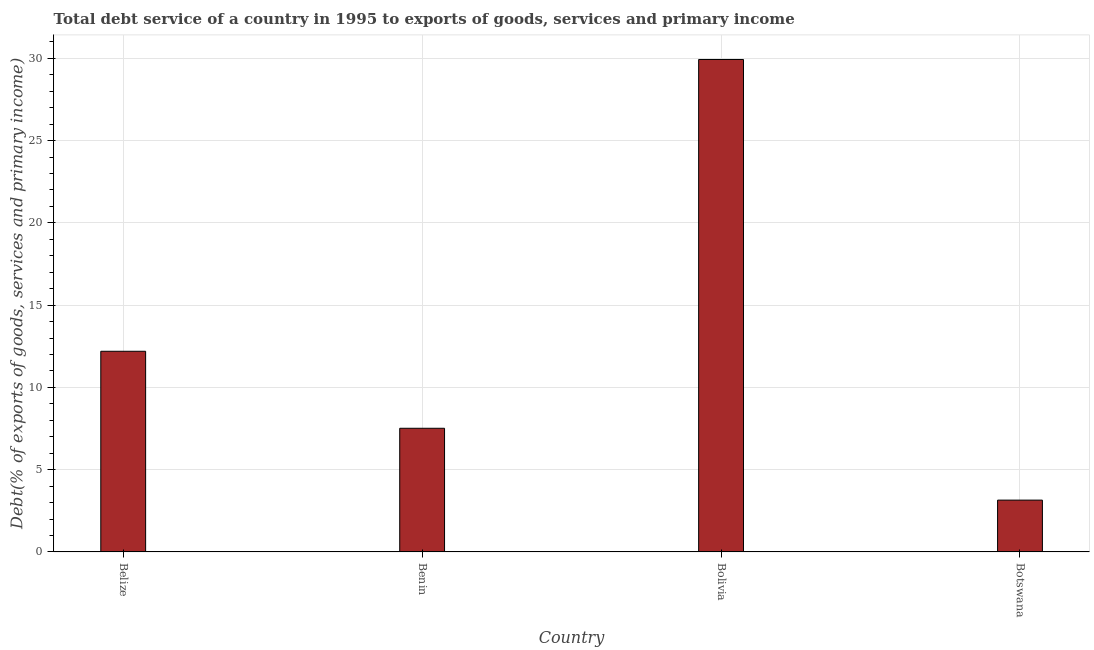Does the graph contain grids?
Make the answer very short. Yes. What is the title of the graph?
Give a very brief answer. Total debt service of a country in 1995 to exports of goods, services and primary income. What is the label or title of the Y-axis?
Offer a terse response. Debt(% of exports of goods, services and primary income). What is the total debt service in Botswana?
Make the answer very short. 3.15. Across all countries, what is the maximum total debt service?
Your answer should be very brief. 29.93. Across all countries, what is the minimum total debt service?
Your answer should be compact. 3.15. In which country was the total debt service maximum?
Provide a short and direct response. Bolivia. In which country was the total debt service minimum?
Keep it short and to the point. Botswana. What is the sum of the total debt service?
Offer a very short reply. 52.78. What is the difference between the total debt service in Bolivia and Botswana?
Your answer should be compact. 26.78. What is the average total debt service per country?
Your answer should be compact. 13.2. What is the median total debt service?
Offer a very short reply. 9.85. In how many countries, is the total debt service greater than 9 %?
Provide a short and direct response. 2. What is the ratio of the total debt service in Benin to that in Bolivia?
Keep it short and to the point. 0.25. Is the total debt service in Benin less than that in Botswana?
Your answer should be compact. No. Is the difference between the total debt service in Belize and Benin greater than the difference between any two countries?
Give a very brief answer. No. What is the difference between the highest and the second highest total debt service?
Offer a very short reply. 17.73. Is the sum of the total debt service in Bolivia and Botswana greater than the maximum total debt service across all countries?
Your response must be concise. Yes. What is the difference between the highest and the lowest total debt service?
Ensure brevity in your answer.  26.78. In how many countries, is the total debt service greater than the average total debt service taken over all countries?
Offer a very short reply. 1. Are all the bars in the graph horizontal?
Provide a succinct answer. No. Are the values on the major ticks of Y-axis written in scientific E-notation?
Ensure brevity in your answer.  No. What is the Debt(% of exports of goods, services and primary income) in Belize?
Provide a short and direct response. 12.19. What is the Debt(% of exports of goods, services and primary income) in Benin?
Provide a short and direct response. 7.51. What is the Debt(% of exports of goods, services and primary income) of Bolivia?
Ensure brevity in your answer.  29.93. What is the Debt(% of exports of goods, services and primary income) of Botswana?
Your answer should be compact. 3.15. What is the difference between the Debt(% of exports of goods, services and primary income) in Belize and Benin?
Keep it short and to the point. 4.68. What is the difference between the Debt(% of exports of goods, services and primary income) in Belize and Bolivia?
Keep it short and to the point. -17.73. What is the difference between the Debt(% of exports of goods, services and primary income) in Belize and Botswana?
Ensure brevity in your answer.  9.05. What is the difference between the Debt(% of exports of goods, services and primary income) in Benin and Bolivia?
Keep it short and to the point. -22.41. What is the difference between the Debt(% of exports of goods, services and primary income) in Benin and Botswana?
Provide a succinct answer. 4.37. What is the difference between the Debt(% of exports of goods, services and primary income) in Bolivia and Botswana?
Ensure brevity in your answer.  26.78. What is the ratio of the Debt(% of exports of goods, services and primary income) in Belize to that in Benin?
Keep it short and to the point. 1.62. What is the ratio of the Debt(% of exports of goods, services and primary income) in Belize to that in Bolivia?
Your answer should be very brief. 0.41. What is the ratio of the Debt(% of exports of goods, services and primary income) in Belize to that in Botswana?
Give a very brief answer. 3.87. What is the ratio of the Debt(% of exports of goods, services and primary income) in Benin to that in Bolivia?
Offer a very short reply. 0.25. What is the ratio of the Debt(% of exports of goods, services and primary income) in Benin to that in Botswana?
Your answer should be very brief. 2.39. What is the ratio of the Debt(% of exports of goods, services and primary income) in Bolivia to that in Botswana?
Provide a succinct answer. 9.51. 